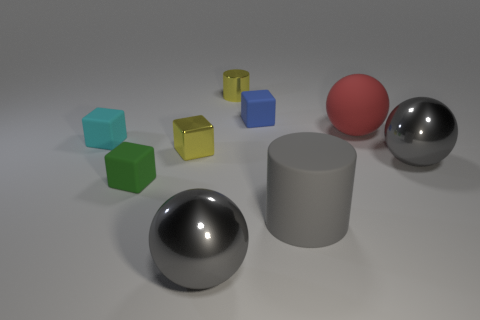Subtract 1 blocks. How many blocks are left? 3 Subtract all yellow balls. Subtract all gray blocks. How many balls are left? 3 Add 1 large cyan blocks. How many objects exist? 10 Subtract all cylinders. How many objects are left? 7 Subtract 0 purple spheres. How many objects are left? 9 Subtract all small cyan balls. Subtract all large gray metallic things. How many objects are left? 7 Add 6 big red spheres. How many big red spheres are left? 7 Add 6 tiny blue rubber objects. How many tiny blue rubber objects exist? 7 